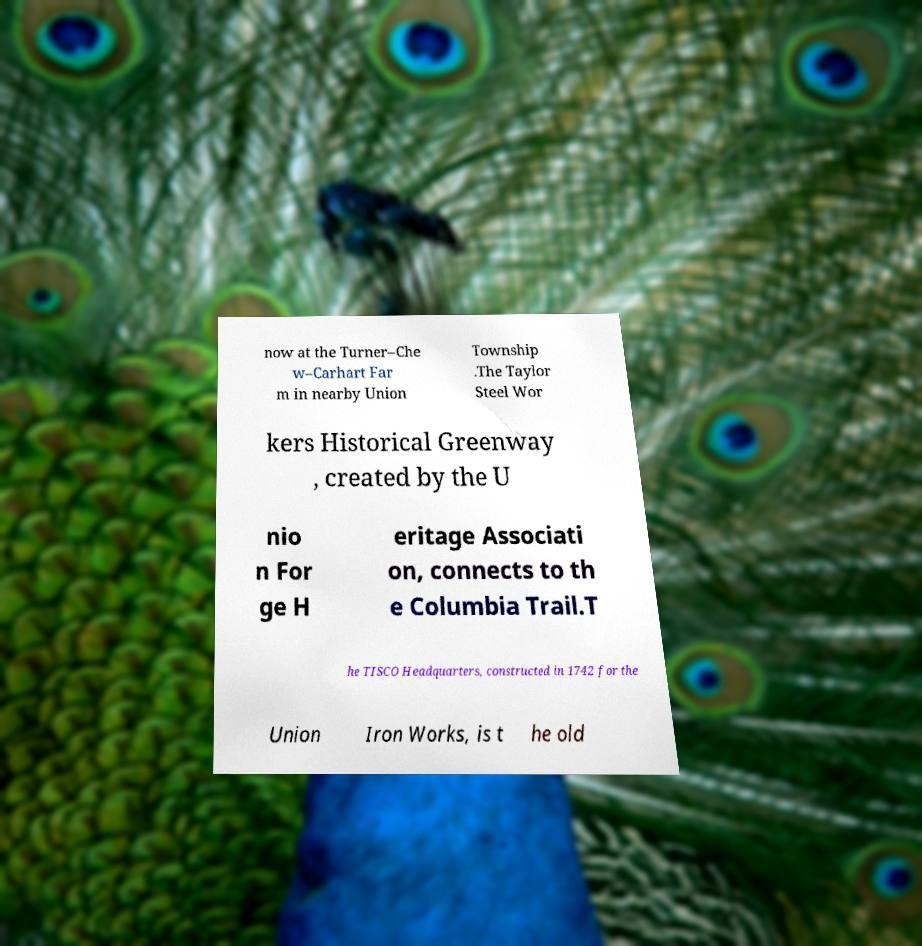Please identify and transcribe the text found in this image. now at the Turner–Che w–Carhart Far m in nearby Union Township .The Taylor Steel Wor kers Historical Greenway , created by the U nio n For ge H eritage Associati on, connects to th e Columbia Trail.T he TISCO Headquarters, constructed in 1742 for the Union Iron Works, is t he old 